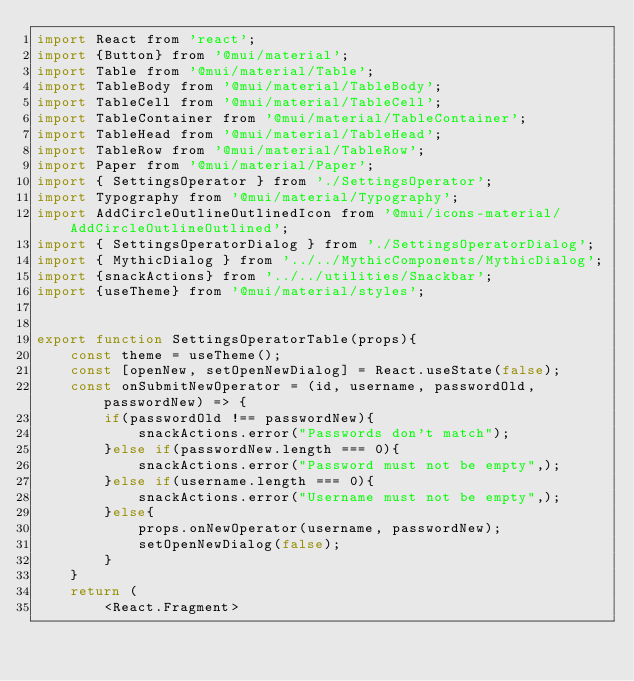<code> <loc_0><loc_0><loc_500><loc_500><_JavaScript_>import React from 'react';
import {Button} from '@mui/material';
import Table from '@mui/material/Table';
import TableBody from '@mui/material/TableBody';
import TableCell from '@mui/material/TableCell';
import TableContainer from '@mui/material/TableContainer';
import TableHead from '@mui/material/TableHead';
import TableRow from '@mui/material/TableRow';
import Paper from '@mui/material/Paper';
import { SettingsOperator } from './SettingsOperator';
import Typography from '@mui/material/Typography';
import AddCircleOutlineOutlinedIcon from '@mui/icons-material/AddCircleOutlineOutlined';
import { SettingsOperatorDialog } from './SettingsOperatorDialog';
import { MythicDialog } from '../../MythicComponents/MythicDialog';
import {snackActions} from '../../utilities/Snackbar';
import {useTheme} from '@mui/material/styles';


export function SettingsOperatorTable(props){
    const theme = useTheme();
    const [openNew, setOpenNewDialog] = React.useState(false);
    const onSubmitNewOperator = (id, username, passwordOld, passwordNew) => {
        if(passwordOld !== passwordNew){
            snackActions.error("Passwords don't match");
        }else if(passwordNew.length === 0){
            snackActions.error("Password must not be empty",);
        }else if(username.length === 0){
            snackActions.error("Username must not be empty",);
        }else{
            props.onNewOperator(username, passwordNew);
            setOpenNewDialog(false);
        }
    }
    return (
        <React.Fragment></code> 